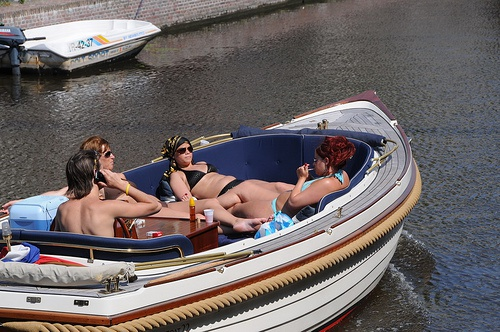Describe the objects in this image and their specific colors. I can see boat in gray, lightgray, black, and darkgray tones, boat in gray, white, black, and darkgray tones, people in gray, tan, black, and salmon tones, people in gray, salmon, brown, black, and maroon tones, and people in gray, black, brown, maroon, and salmon tones in this image. 